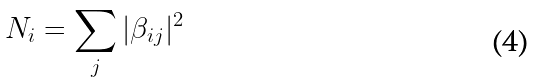Convert formula to latex. <formula><loc_0><loc_0><loc_500><loc_500>N _ { i } = \sum _ { j } | \beta _ { i j } | ^ { 2 }</formula> 